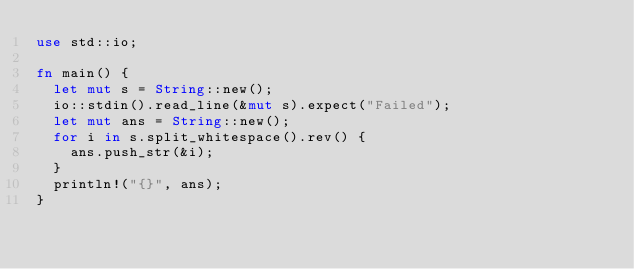Convert code to text. <code><loc_0><loc_0><loc_500><loc_500><_Rust_>use std::io;

fn main() {
	let mut s = String::new();
	io::stdin().read_line(&mut s).expect("Failed");
	let mut ans = String::new();
	for i in s.split_whitespace().rev() {
		ans.push_str(&i);
	}
	println!("{}", ans);
}
</code> 